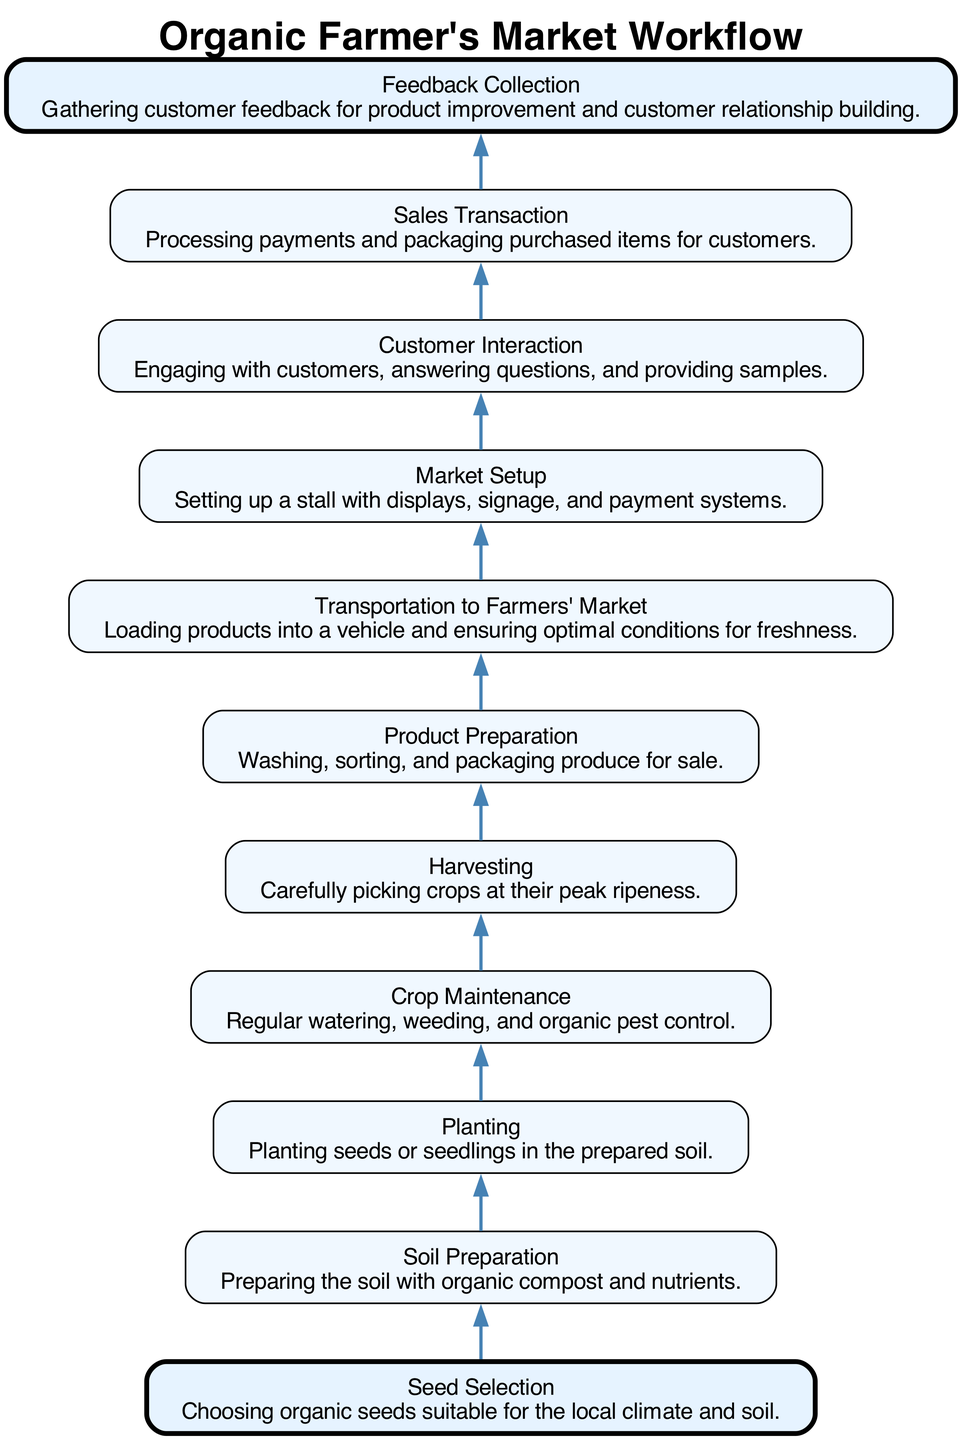What is the first step in the workflow? The first step is labeled as "Seed Selection," which indicates the initial action in the workflow.
Answer: Seed Selection How many steps are included in the workflow? By counting the nodes in the diagram, there are a total of 11 distinct steps in the workflow.
Answer: 11 What step comes after "Planting"? The diagram shows that the step immediately following "Planting" is "Crop Maintenance," indicating the next action in the sequence.
Answer: Crop Maintenance Which step involves engaging with customers? The step labeled "Customer Interaction" describes the process of engaging with customers, including answering questions and providing samples.
Answer: Customer Interaction What is the last step in the workflow? The last step is "Feedback Collection," indicating that the workflow concludes with gathering customer feedback for improvement.
Answer: Feedback Collection What relationship exists between "Harvesting" and "Product Preparation"? The diagram indicates that "Harvesting" leads directly to "Product Preparation," showing that these steps are sequential in the workflow.
Answer: Sequential In how many steps does the word "organic" appear? The term "organic" appears in three steps throughout the workflow, specifically in "Seed Selection," "Soil Preparation," and "Crop Maintenance."
Answer: 3 What form of transportation is involved in the workflow? The step "Transportation to Farmers' Market" specifies that there is a transportation component involved in the workflow for the products.
Answer: Transportation Which step has the highest emphasis in the diagram? The steps "Seed Selection" and "Feedback Collection" are highlighted with a different color and increased pen width, providing them with the highest emphasis in the diagram.
Answer: Seed Selection and Feedback Collection What does "Sales Transaction" involve? The "Sales Transaction" step includes the processing of payments and the packaging of purchased items for customers, detailing this aspect of customer interaction.
Answer: Processing payments and packaging purchased items 